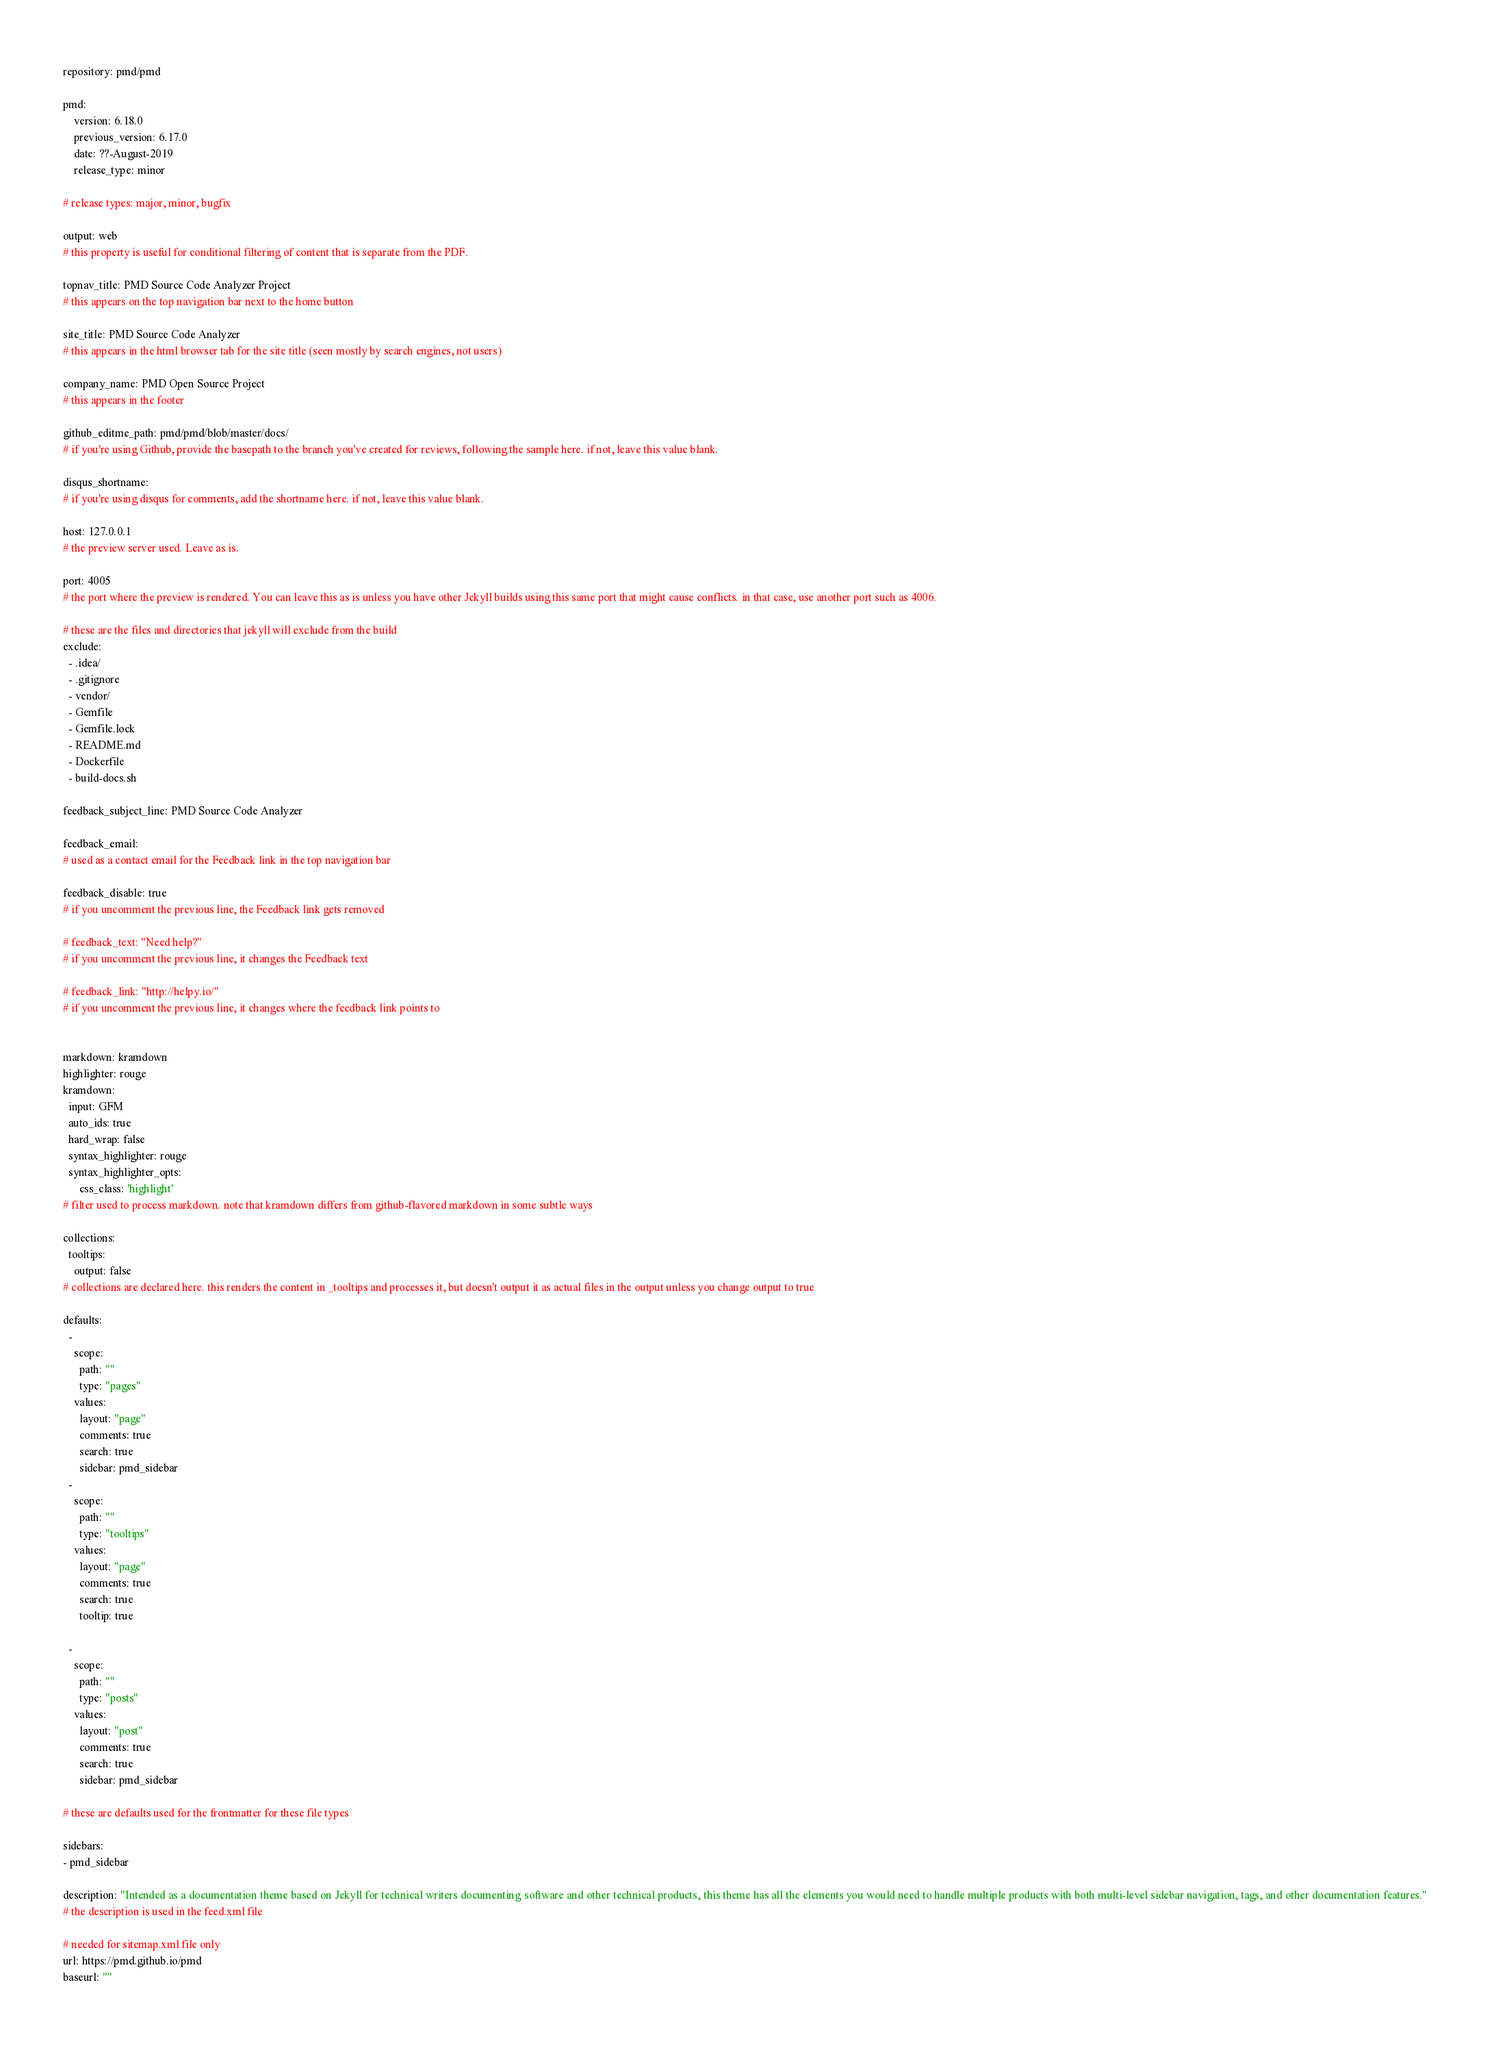<code> <loc_0><loc_0><loc_500><loc_500><_YAML_>repository: pmd/pmd

pmd:
    version: 6.18.0
    previous_version: 6.17.0
    date: ??-August-2019
    release_type: minor

# release types: major, minor, bugfix

output: web
# this property is useful for conditional filtering of content that is separate from the PDF.

topnav_title: PMD Source Code Analyzer Project
# this appears on the top navigation bar next to the home button

site_title: PMD Source Code Analyzer
# this appears in the html browser tab for the site title (seen mostly by search engines, not users)

company_name: PMD Open Source Project
# this appears in the footer

github_editme_path: pmd/pmd/blob/master/docs/
# if you're using Github, provide the basepath to the branch you've created for reviews, following the sample here. if not, leave this value blank.

disqus_shortname:
# if you're using disqus for comments, add the shortname here. if not, leave this value blank.

host: 127.0.0.1
# the preview server used. Leave as is.

port: 4005
# the port where the preview is rendered. You can leave this as is unless you have other Jekyll builds using this same port that might cause conflicts. in that case, use another port such as 4006.

# these are the files and directories that jekyll will exclude from the build
exclude:
  - .idea/
  - .gitignore
  - vendor/
  - Gemfile
  - Gemfile.lock
  - README.md
  - Dockerfile
  - build-docs.sh

feedback_subject_line: PMD Source Code Analyzer

feedback_email:
# used as a contact email for the Feedback link in the top navigation bar

feedback_disable: true
# if you uncomment the previous line, the Feedback link gets removed

# feedback_text: "Need help?"
# if you uncomment the previous line, it changes the Feedback text

# feedback_link: "http://helpy.io/"
# if you uncomment the previous line, it changes where the feedback link points to


markdown: kramdown
highlighter: rouge
kramdown:
  input: GFM
  auto_ids: true
  hard_wrap: false
  syntax_highlighter: rouge
  syntax_highlighter_opts:
      css_class: 'highlight'
# filter used to process markdown. note that kramdown differs from github-flavored markdown in some subtle ways

collections:
  tooltips:
    output: false
# collections are declared here. this renders the content in _tooltips and processes it, but doesn't output it as actual files in the output unless you change output to true

defaults:
  -
    scope:
      path: ""
      type: "pages"
    values:
      layout: "page"
      comments: true
      search: true
      sidebar: pmd_sidebar
  -
    scope:
      path: ""
      type: "tooltips"
    values:
      layout: "page"
      comments: true
      search: true
      tooltip: true

  -
    scope:
      path: ""
      type: "posts"
    values:
      layout: "post"
      comments: true
      search: true
      sidebar: pmd_sidebar

# these are defaults used for the frontmatter for these file types

sidebars:
- pmd_sidebar

description: "Intended as a documentation theme based on Jekyll for technical writers documenting software and other technical products, this theme has all the elements you would need to handle multiple products with both multi-level sidebar navigation, tags, and other documentation features."
# the description is used in the feed.xml file

# needed for sitemap.xml file only
url: https://pmd.github.io/pmd
baseurl: ""
</code> 